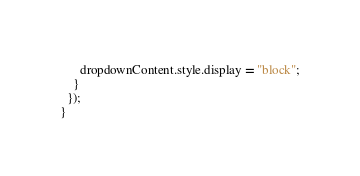<code> <loc_0><loc_0><loc_500><loc_500><_JavaScript_>      dropdownContent.style.display = "block";
    }
  });
}
</code> 